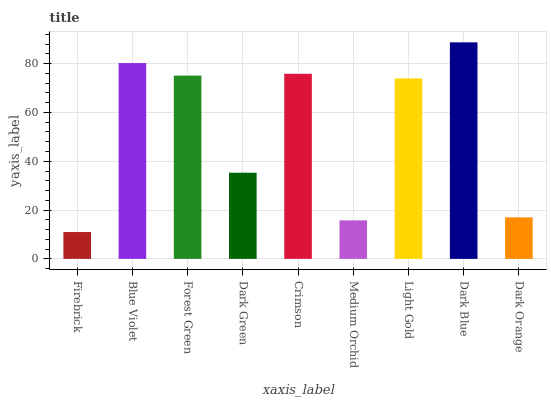Is Firebrick the minimum?
Answer yes or no. Yes. Is Dark Blue the maximum?
Answer yes or no. Yes. Is Blue Violet the minimum?
Answer yes or no. No. Is Blue Violet the maximum?
Answer yes or no. No. Is Blue Violet greater than Firebrick?
Answer yes or no. Yes. Is Firebrick less than Blue Violet?
Answer yes or no. Yes. Is Firebrick greater than Blue Violet?
Answer yes or no. No. Is Blue Violet less than Firebrick?
Answer yes or no. No. Is Light Gold the high median?
Answer yes or no. Yes. Is Light Gold the low median?
Answer yes or no. Yes. Is Dark Blue the high median?
Answer yes or no. No. Is Firebrick the low median?
Answer yes or no. No. 